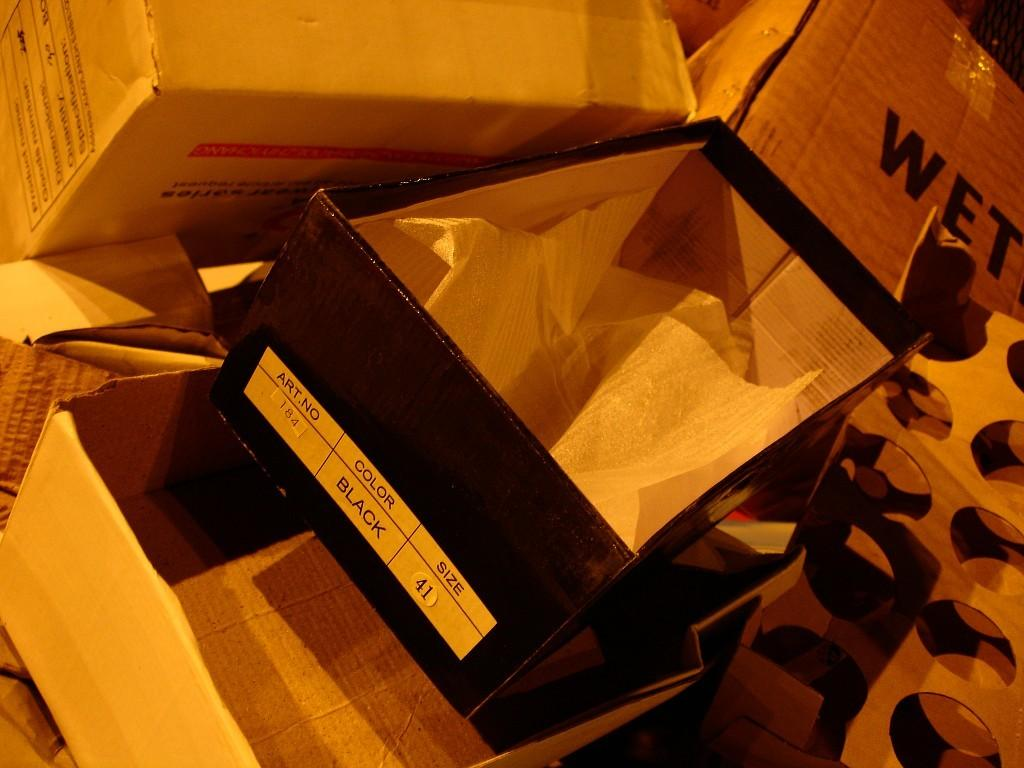<image>
Write a terse but informative summary of the picture. many open shoe boxes on the floor with labels like Black and WET 